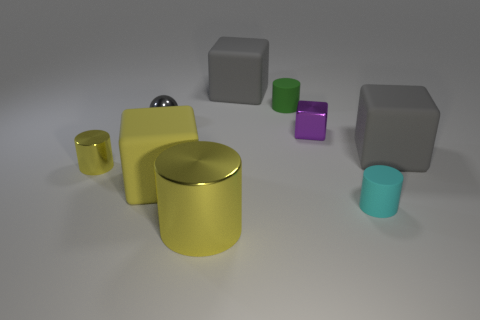How many other things are there of the same material as the small purple block? There are three other blocks that appear to be made of the same matte material as the small purple block. These include one grey block that is up in the air, another grey block resting on the ground, and a small green block. They share a similar matte finish and solid color characteristic, suggesting they are made from the same or similar material. 